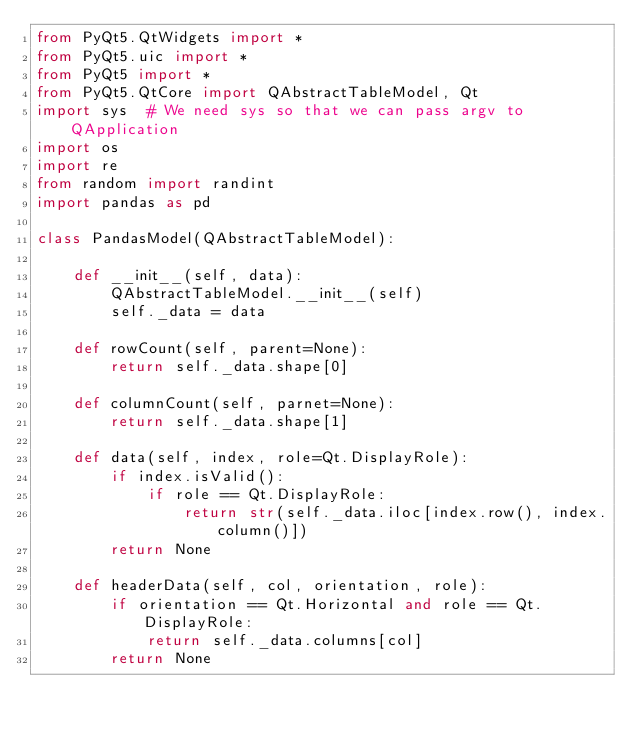<code> <loc_0><loc_0><loc_500><loc_500><_Python_>from PyQt5.QtWidgets import *
from PyQt5.uic import *
from PyQt5 import *
from PyQt5.QtCore import QAbstractTableModel, Qt
import sys  # We need sys so that we can pass argv to QApplication
import os
import re
from random import randint
import pandas as pd

class PandasModel(QAbstractTableModel):

    def __init__(self, data):
        QAbstractTableModel.__init__(self)
        self._data = data

    def rowCount(self, parent=None):
        return self._data.shape[0]

    def columnCount(self, parnet=None):
        return self._data.shape[1]

    def data(self, index, role=Qt.DisplayRole):
        if index.isValid():
            if role == Qt.DisplayRole:
                return str(self._data.iloc[index.row(), index.column()])
        return None

    def headerData(self, col, orientation, role):
        if orientation == Qt.Horizontal and role == Qt.DisplayRole:
            return self._data.columns[col]
        return None
</code> 